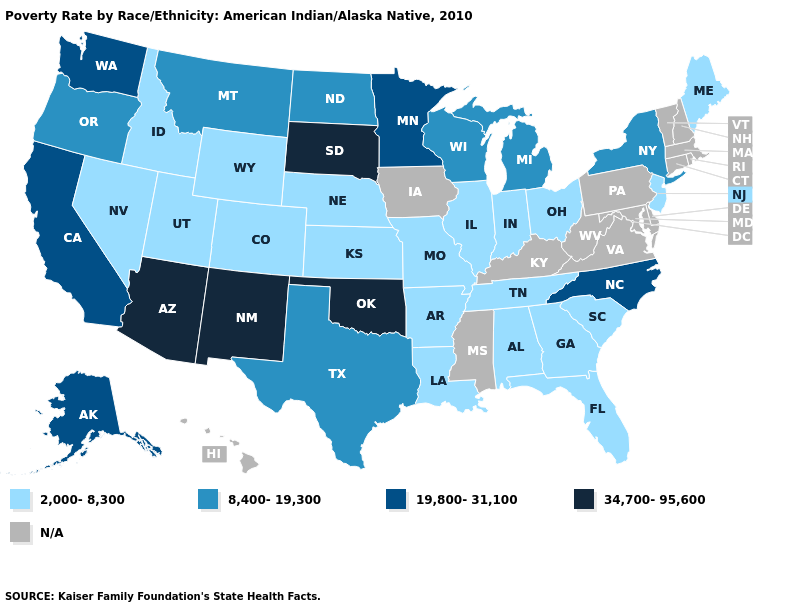Which states have the highest value in the USA?
Keep it brief. Arizona, New Mexico, Oklahoma, South Dakota. What is the value of Delaware?
Give a very brief answer. N/A. What is the value of Pennsylvania?
Short answer required. N/A. Does Oklahoma have the lowest value in the South?
Write a very short answer. No. What is the value of Nevada?
Give a very brief answer. 2,000-8,300. Among the states that border Washington , does Oregon have the highest value?
Quick response, please. Yes. What is the value of Nebraska?
Quick response, please. 2,000-8,300. Does the map have missing data?
Give a very brief answer. Yes. Among the states that border Arkansas , which have the highest value?
Write a very short answer. Oklahoma. Which states have the lowest value in the South?
Short answer required. Alabama, Arkansas, Florida, Georgia, Louisiana, South Carolina, Tennessee. Name the states that have a value in the range 2,000-8,300?
Write a very short answer. Alabama, Arkansas, Colorado, Florida, Georgia, Idaho, Illinois, Indiana, Kansas, Louisiana, Maine, Missouri, Nebraska, Nevada, New Jersey, Ohio, South Carolina, Tennessee, Utah, Wyoming. What is the value of New Mexico?
Quick response, please. 34,700-95,600. 